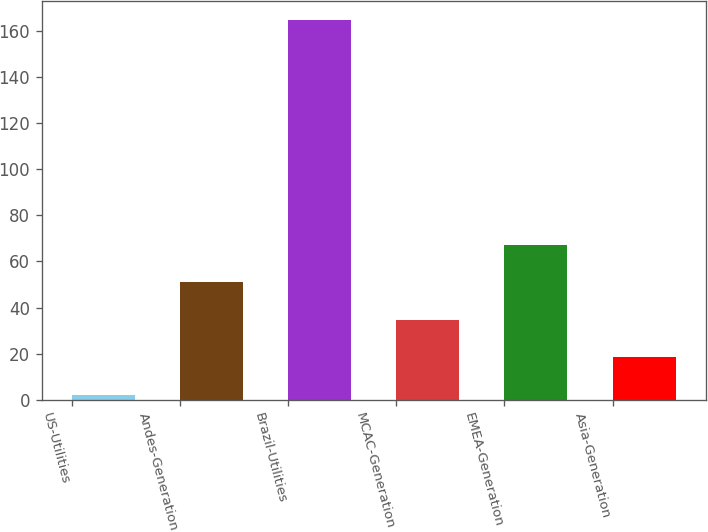Convert chart to OTSL. <chart><loc_0><loc_0><loc_500><loc_500><bar_chart><fcel>US-Utilities<fcel>Andes-Generation<fcel>Brazil-Utilities<fcel>MCAC-Generation<fcel>EMEA-Generation<fcel>Asia-Generation<nl><fcel>2<fcel>50.9<fcel>165<fcel>34.6<fcel>67.2<fcel>18.3<nl></chart> 